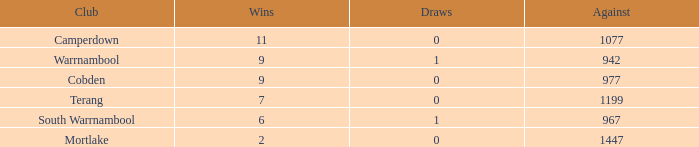How many draws did Mortlake have when the losses were more than 5? 1.0. Can you parse all the data within this table? {'header': ['Club', 'Wins', 'Draws', 'Against'], 'rows': [['Camperdown', '11', '0', '1077'], ['Warrnambool', '9', '1', '942'], ['Cobden', '9', '0', '977'], ['Terang', '7', '0', '1199'], ['South Warrnambool', '6', '1', '967'], ['Mortlake', '2', '0', '1447']]} 